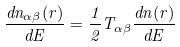Convert formula to latex. <formula><loc_0><loc_0><loc_500><loc_500>\frac { d n _ { \alpha \beta } ( { r } ) } { d E } = \frac { 1 } { 2 } T _ { \alpha \beta } \frac { d n ( { r } ) } { d E }</formula> 